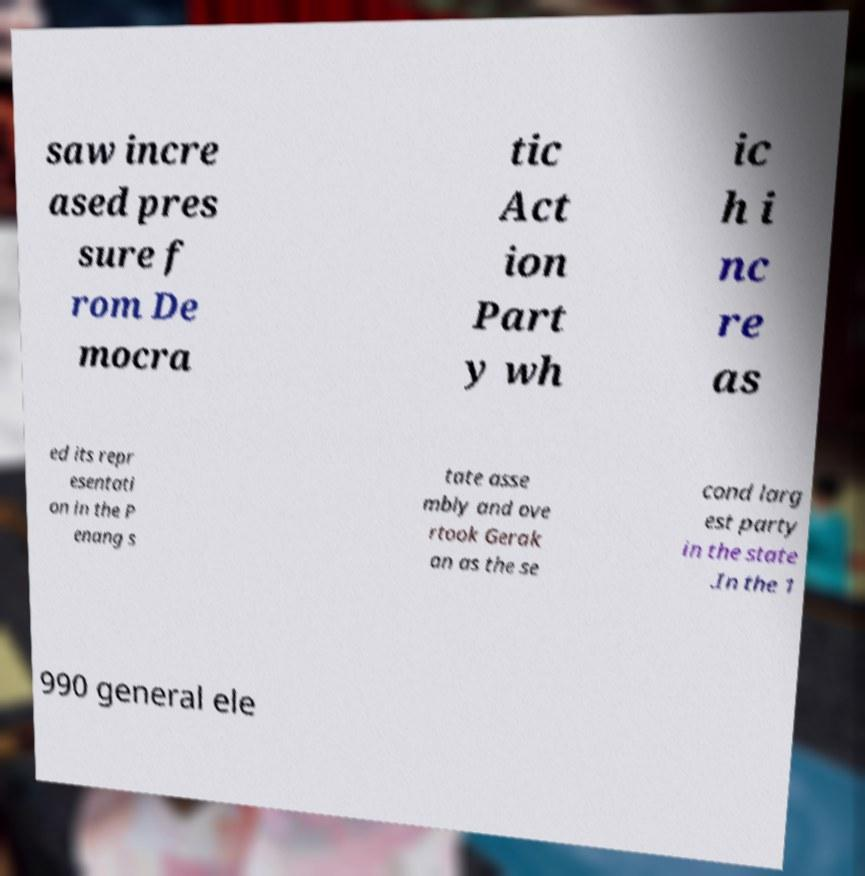Please read and relay the text visible in this image. What does it say? saw incre ased pres sure f rom De mocra tic Act ion Part y wh ic h i nc re as ed its repr esentati on in the P enang s tate asse mbly and ove rtook Gerak an as the se cond larg est party in the state .In the 1 990 general ele 